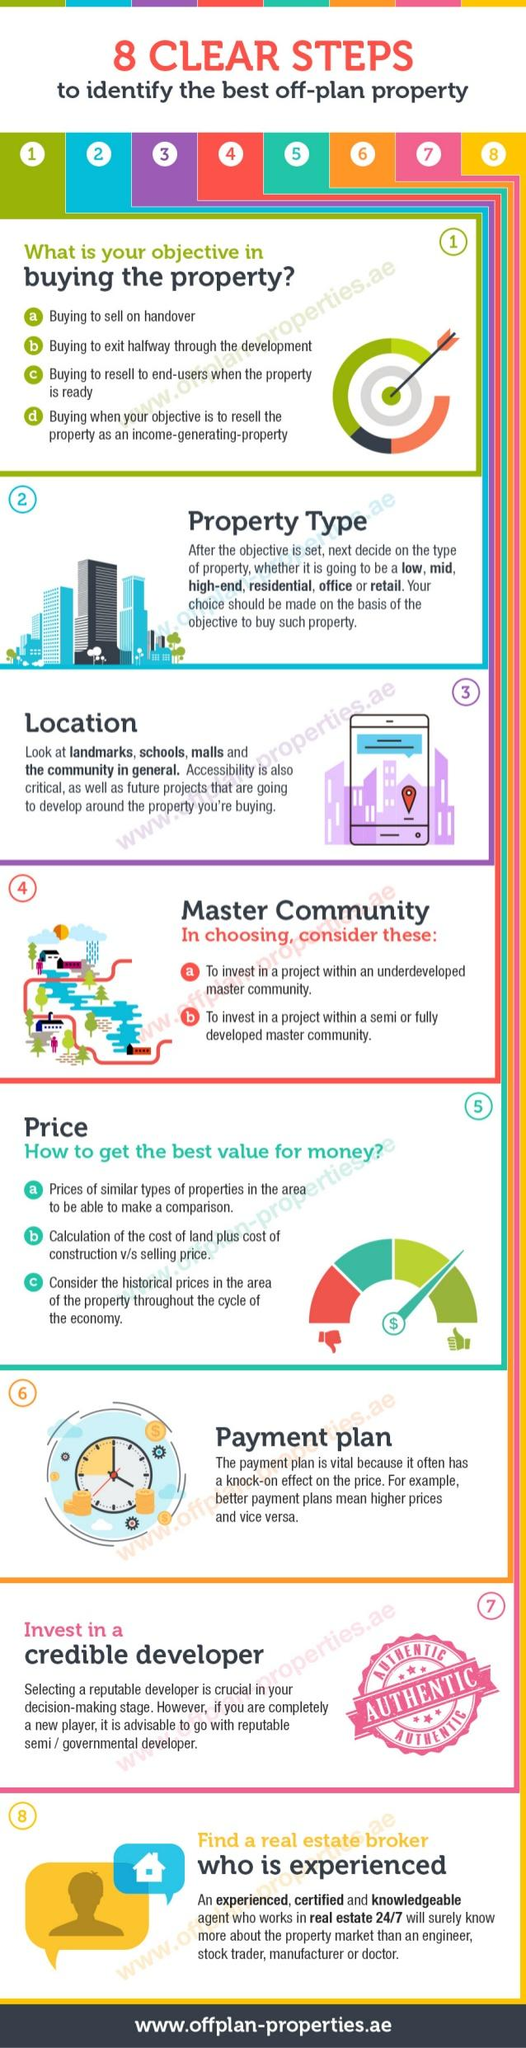Give some essential details in this illustration. The infographic lists 4 objectives for buying a property. The number of factors considered in selecting a master's community is two. 